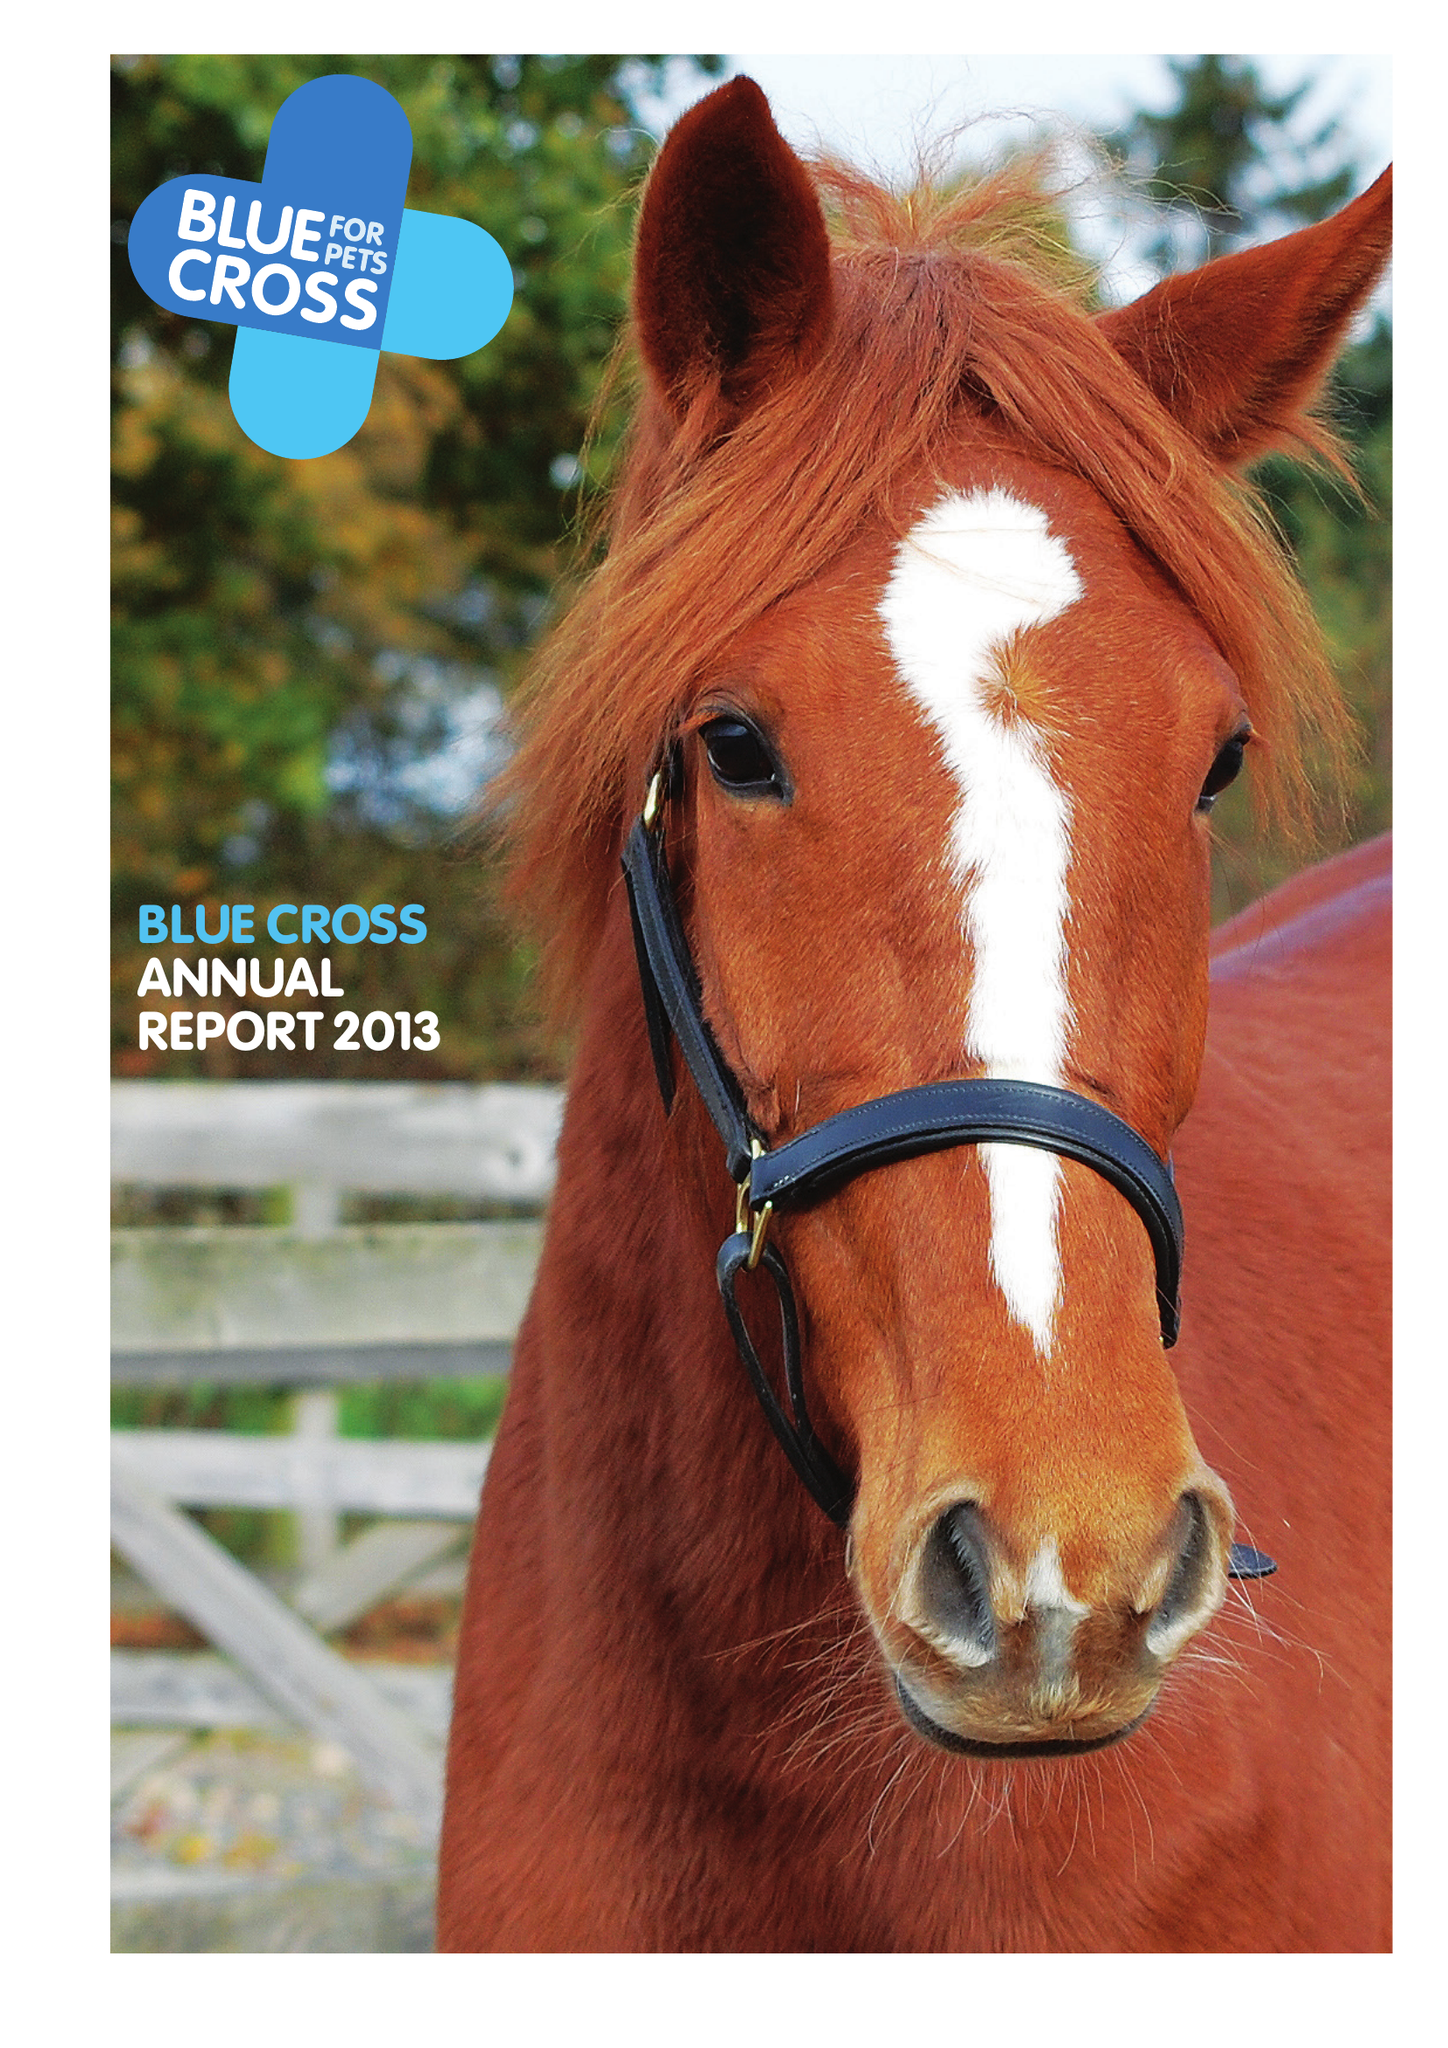What is the value for the charity_number?
Answer the question using a single word or phrase. 224392 